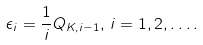<formula> <loc_0><loc_0><loc_500><loc_500>\epsilon _ { i } = \frac { 1 } { i } Q _ { K , i - 1 } , \, i = 1 , 2 , \dots .</formula> 